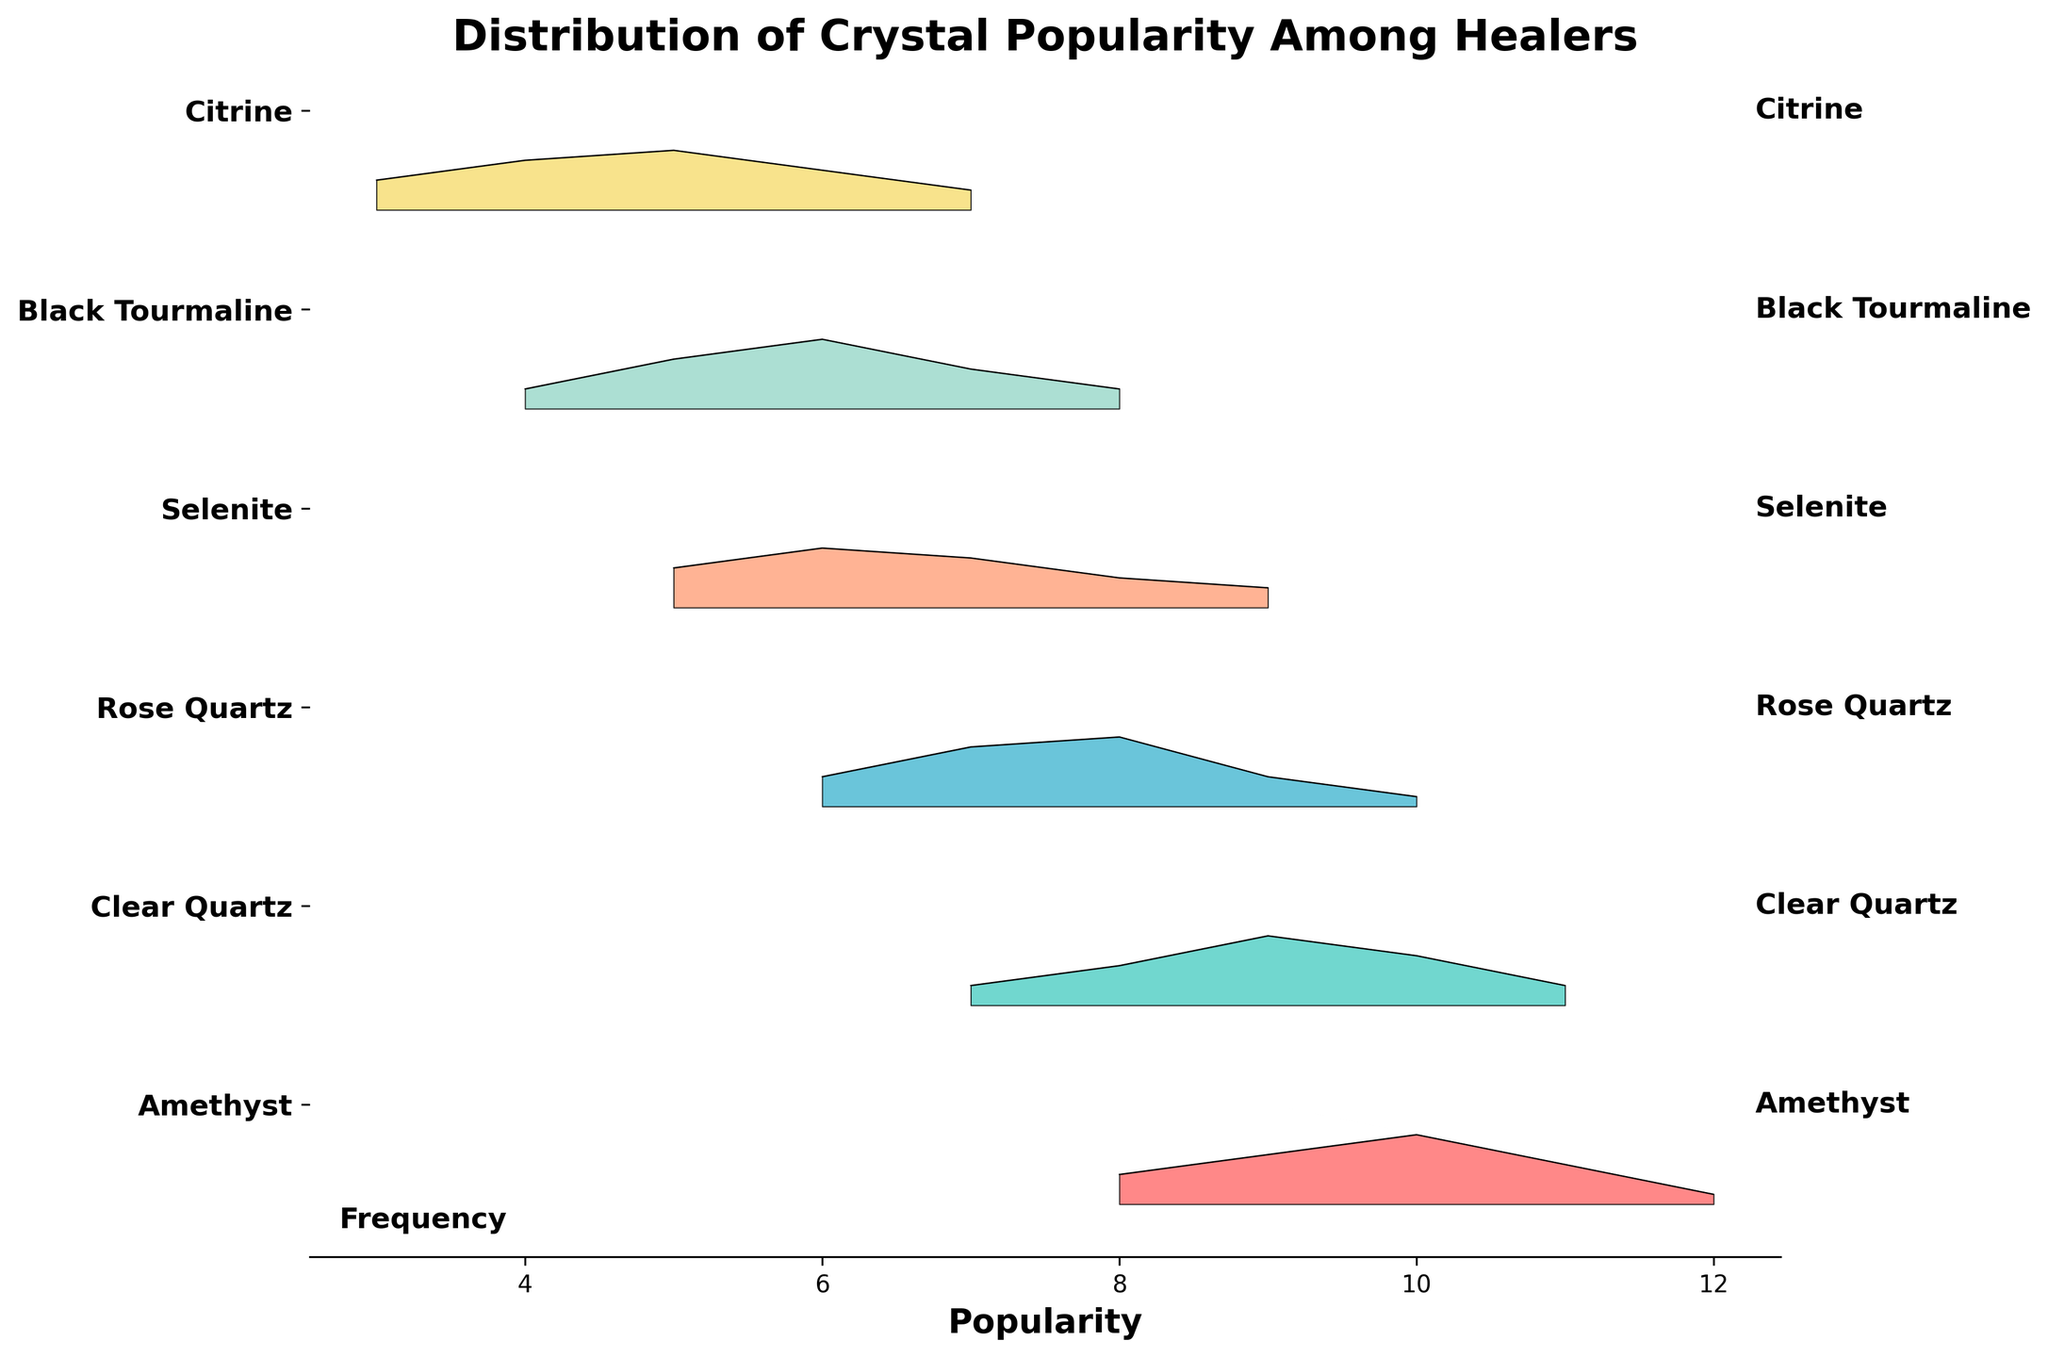what's the title of the figure? The title is prominently located at the top of the plot. It clearly states the primary focus of the data being shown.
Answer: Distribution of Crystal Popularity Among Healers what is the range of popularity for Amethyst? To determine this, look at the x-axis values where the ridgeline plot for Amethyst is filled. The plot spans from the popularity value of 8 to 12.
Answer: 8 to 12 which crystal type has the highest peak frequency value and what is that value? By inspecting the heights of the ridgelines, the peak frequency value is identified by the tallest peak. The crystal type at this peak is likely the one with the highest value.
Answer: Amethyst, 0.35 how do the popularity distributions of Amethyst and Clear Quartz compare? Compare the ridgelines of Amethyst and Clear Quartz. Amethyst has a more spread-out popularity distribution while Clear Quartz exhibits a peak around 9, implying more uniform popularity among healers.
Answer: Amethyst is more spread out, Clear Quartz peaks at 9 what's the average popularity value for Rose Quartz? To calculate the average popularity, sum up the products of popularity and frequency for Rose Quartz, then divide by the total frequency. \( \text{Average} = \frac{6 \times 0.15 + 7 \times 0.30 + 8 \times 0.35 + 9 \times 0.15 + 10 \times 0.05}{0.15 + 0.30 + 0.35 + 0.15 + 0.05} = 7.5 \)
Answer: 7.5 is Selenite more popular than Citrine on average? Calculate the average popularity for both crystals. If Selenite's average is higher, then it is more popular. 
Selenite: \( \frac{5 \times 0.20 + 6 \times 0.30 + 7 \times 0.25 + 8 \times 0.15 + 9 \times 0.10}{0.20 + 0.30 + 0.25 + 0.15 + 0.10} = 6.5 \) 
Citrine: \( \frac{3 \times 0.15 + 4 \times 0.25 + 5 \times 0.30 + 6 \times 0.20 + 7 \times 0.10}{0.15 + 0.25 + 0.30 + 0.20 + 0.10} = 5.0 \) 
Hence, Selenite is more popular than Citrine on average.
Answer: Yes which crystal type has the broadest range of popularity values and what is that range? To answer this, look at each ridgeline plot and identify the one with the widest span on the x-axis. The range is determined by the lowest and highest popularity values shown.
Answer: Selenite, from 5 to 9 how does the frequency distribution for Black Tourmaline compare to Citrine? Compare the height and spread of the ridgelines. Black Tourmaline’s ridgeline spans from 4 to 8 with peak frequency at 6, while Citrine’s spans from 3 to 7 with peak frequency at 5. They're both quite similar but Black Tourmaline's distribution is slightly broader and a bit more skewed to the right.
Answer: Similar distribution, Black Tourmaline spans broader and peaks at 6, Citrine peaks at 5 